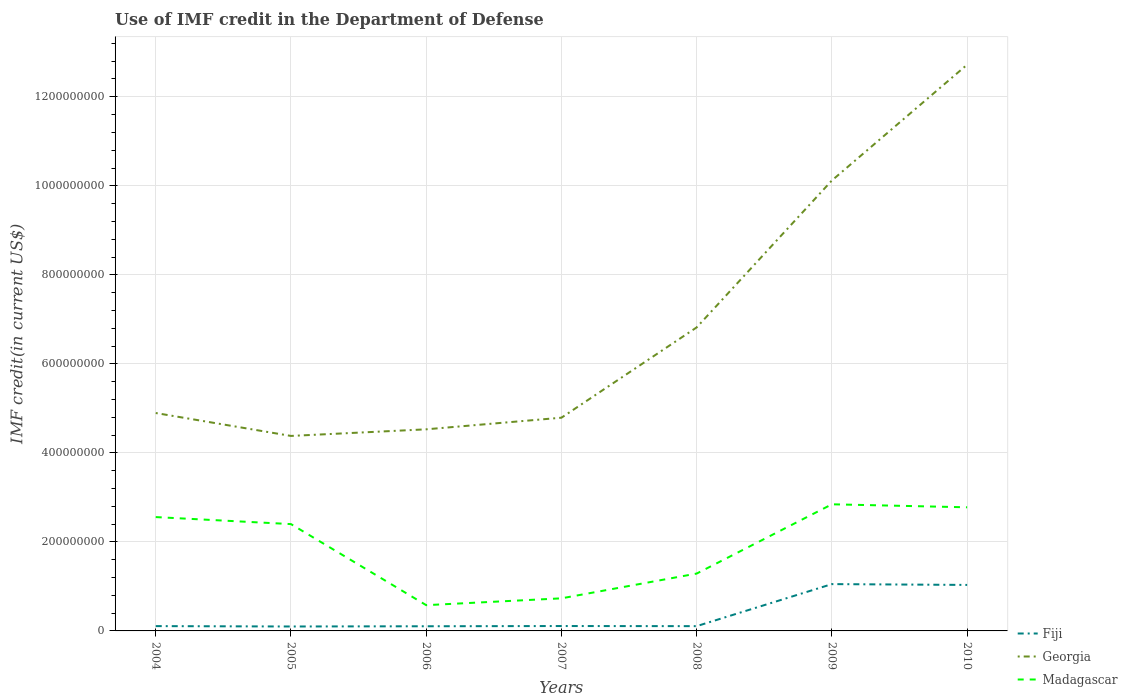How many different coloured lines are there?
Give a very brief answer. 3. Is the number of lines equal to the number of legend labels?
Your answer should be very brief. Yes. Across all years, what is the maximum IMF credit in the Department of Defense in Fiji?
Give a very brief answer. 9.94e+06. What is the total IMF credit in the Department of Defense in Fiji in the graph?
Keep it short and to the point. -1.89e+05. What is the difference between the highest and the second highest IMF credit in the Department of Defense in Georgia?
Keep it short and to the point. 8.34e+08. What is the difference between the highest and the lowest IMF credit in the Department of Defense in Madagascar?
Keep it short and to the point. 4. Is the IMF credit in the Department of Defense in Fiji strictly greater than the IMF credit in the Department of Defense in Georgia over the years?
Keep it short and to the point. Yes. How many lines are there?
Make the answer very short. 3. How many years are there in the graph?
Offer a terse response. 7. Are the values on the major ticks of Y-axis written in scientific E-notation?
Keep it short and to the point. No. Does the graph contain any zero values?
Your response must be concise. No. Where does the legend appear in the graph?
Your answer should be very brief. Bottom right. How are the legend labels stacked?
Offer a very short reply. Vertical. What is the title of the graph?
Ensure brevity in your answer.  Use of IMF credit in the Department of Defense. Does "Philippines" appear as one of the legend labels in the graph?
Your answer should be very brief. No. What is the label or title of the X-axis?
Your answer should be compact. Years. What is the label or title of the Y-axis?
Provide a succinct answer. IMF credit(in current US$). What is the IMF credit(in current US$) in Fiji in 2004?
Give a very brief answer. 1.08e+07. What is the IMF credit(in current US$) of Georgia in 2004?
Your answer should be very brief. 4.90e+08. What is the IMF credit(in current US$) of Madagascar in 2004?
Provide a short and direct response. 2.56e+08. What is the IMF credit(in current US$) in Fiji in 2005?
Give a very brief answer. 9.94e+06. What is the IMF credit(in current US$) in Georgia in 2005?
Your answer should be very brief. 4.38e+08. What is the IMF credit(in current US$) of Madagascar in 2005?
Give a very brief answer. 2.40e+08. What is the IMF credit(in current US$) of Fiji in 2006?
Your response must be concise. 1.05e+07. What is the IMF credit(in current US$) of Georgia in 2006?
Ensure brevity in your answer.  4.53e+08. What is the IMF credit(in current US$) in Madagascar in 2006?
Make the answer very short. 5.79e+07. What is the IMF credit(in current US$) of Fiji in 2007?
Offer a terse response. 1.10e+07. What is the IMF credit(in current US$) in Georgia in 2007?
Your answer should be very brief. 4.79e+08. What is the IMF credit(in current US$) in Madagascar in 2007?
Your answer should be very brief. 7.32e+07. What is the IMF credit(in current US$) in Fiji in 2008?
Give a very brief answer. 1.07e+07. What is the IMF credit(in current US$) of Georgia in 2008?
Make the answer very short. 6.82e+08. What is the IMF credit(in current US$) in Madagascar in 2008?
Offer a terse response. 1.29e+08. What is the IMF credit(in current US$) in Fiji in 2009?
Make the answer very short. 1.05e+08. What is the IMF credit(in current US$) in Georgia in 2009?
Your response must be concise. 1.01e+09. What is the IMF credit(in current US$) in Madagascar in 2009?
Offer a terse response. 2.84e+08. What is the IMF credit(in current US$) of Fiji in 2010?
Offer a terse response. 1.03e+08. What is the IMF credit(in current US$) of Georgia in 2010?
Keep it short and to the point. 1.27e+09. What is the IMF credit(in current US$) of Madagascar in 2010?
Your answer should be compact. 2.78e+08. Across all years, what is the maximum IMF credit(in current US$) in Fiji?
Your answer should be very brief. 1.05e+08. Across all years, what is the maximum IMF credit(in current US$) in Georgia?
Your answer should be very brief. 1.27e+09. Across all years, what is the maximum IMF credit(in current US$) of Madagascar?
Give a very brief answer. 2.84e+08. Across all years, what is the minimum IMF credit(in current US$) of Fiji?
Offer a terse response. 9.94e+06. Across all years, what is the minimum IMF credit(in current US$) in Georgia?
Provide a short and direct response. 4.38e+08. Across all years, what is the minimum IMF credit(in current US$) of Madagascar?
Provide a short and direct response. 5.79e+07. What is the total IMF credit(in current US$) of Fiji in the graph?
Make the answer very short. 2.61e+08. What is the total IMF credit(in current US$) in Georgia in the graph?
Provide a succinct answer. 4.83e+09. What is the total IMF credit(in current US$) of Madagascar in the graph?
Your answer should be compact. 1.32e+09. What is the difference between the IMF credit(in current US$) of Fiji in 2004 and that in 2005?
Make the answer very short. 8.61e+05. What is the difference between the IMF credit(in current US$) of Georgia in 2004 and that in 2005?
Ensure brevity in your answer.  5.15e+07. What is the difference between the IMF credit(in current US$) in Madagascar in 2004 and that in 2005?
Make the answer very short. 1.58e+07. What is the difference between the IMF credit(in current US$) of Fiji in 2004 and that in 2006?
Give a very brief answer. 3.38e+05. What is the difference between the IMF credit(in current US$) in Georgia in 2004 and that in 2006?
Ensure brevity in your answer.  3.66e+07. What is the difference between the IMF credit(in current US$) of Madagascar in 2004 and that in 2006?
Your answer should be very brief. 1.98e+08. What is the difference between the IMF credit(in current US$) in Fiji in 2004 and that in 2007?
Give a very brief answer. -1.89e+05. What is the difference between the IMF credit(in current US$) of Georgia in 2004 and that in 2007?
Ensure brevity in your answer.  1.05e+07. What is the difference between the IMF credit(in current US$) of Madagascar in 2004 and that in 2007?
Provide a succinct answer. 1.83e+08. What is the difference between the IMF credit(in current US$) of Fiji in 2004 and that in 2008?
Provide a succinct answer. 8.90e+04. What is the difference between the IMF credit(in current US$) of Georgia in 2004 and that in 2008?
Make the answer very short. -1.92e+08. What is the difference between the IMF credit(in current US$) in Madagascar in 2004 and that in 2008?
Make the answer very short. 1.27e+08. What is the difference between the IMF credit(in current US$) in Fiji in 2004 and that in 2009?
Your answer should be very brief. -9.44e+07. What is the difference between the IMF credit(in current US$) in Georgia in 2004 and that in 2009?
Your response must be concise. -5.22e+08. What is the difference between the IMF credit(in current US$) of Madagascar in 2004 and that in 2009?
Give a very brief answer. -2.87e+07. What is the difference between the IMF credit(in current US$) of Fiji in 2004 and that in 2010?
Your answer should be very brief. -9.25e+07. What is the difference between the IMF credit(in current US$) of Georgia in 2004 and that in 2010?
Offer a terse response. -7.83e+08. What is the difference between the IMF credit(in current US$) in Madagascar in 2004 and that in 2010?
Provide a succinct answer. -2.19e+07. What is the difference between the IMF credit(in current US$) in Fiji in 2005 and that in 2006?
Keep it short and to the point. -5.23e+05. What is the difference between the IMF credit(in current US$) of Georgia in 2005 and that in 2006?
Provide a succinct answer. -1.49e+07. What is the difference between the IMF credit(in current US$) in Madagascar in 2005 and that in 2006?
Offer a terse response. 1.82e+08. What is the difference between the IMF credit(in current US$) of Fiji in 2005 and that in 2007?
Your response must be concise. -1.05e+06. What is the difference between the IMF credit(in current US$) of Georgia in 2005 and that in 2007?
Keep it short and to the point. -4.10e+07. What is the difference between the IMF credit(in current US$) of Madagascar in 2005 and that in 2007?
Ensure brevity in your answer.  1.67e+08. What is the difference between the IMF credit(in current US$) in Fiji in 2005 and that in 2008?
Ensure brevity in your answer.  -7.72e+05. What is the difference between the IMF credit(in current US$) in Georgia in 2005 and that in 2008?
Give a very brief answer. -2.44e+08. What is the difference between the IMF credit(in current US$) in Madagascar in 2005 and that in 2008?
Ensure brevity in your answer.  1.11e+08. What is the difference between the IMF credit(in current US$) of Fiji in 2005 and that in 2009?
Offer a terse response. -9.52e+07. What is the difference between the IMF credit(in current US$) in Georgia in 2005 and that in 2009?
Your response must be concise. -5.74e+08. What is the difference between the IMF credit(in current US$) of Madagascar in 2005 and that in 2009?
Provide a short and direct response. -4.45e+07. What is the difference between the IMF credit(in current US$) of Fiji in 2005 and that in 2010?
Ensure brevity in your answer.  -9.34e+07. What is the difference between the IMF credit(in current US$) in Georgia in 2005 and that in 2010?
Provide a succinct answer. -8.34e+08. What is the difference between the IMF credit(in current US$) of Madagascar in 2005 and that in 2010?
Provide a short and direct response. -3.77e+07. What is the difference between the IMF credit(in current US$) of Fiji in 2006 and that in 2007?
Keep it short and to the point. -5.27e+05. What is the difference between the IMF credit(in current US$) of Georgia in 2006 and that in 2007?
Keep it short and to the point. -2.61e+07. What is the difference between the IMF credit(in current US$) of Madagascar in 2006 and that in 2007?
Make the answer very short. -1.53e+07. What is the difference between the IMF credit(in current US$) in Fiji in 2006 and that in 2008?
Offer a terse response. -2.49e+05. What is the difference between the IMF credit(in current US$) in Georgia in 2006 and that in 2008?
Provide a short and direct response. -2.29e+08. What is the difference between the IMF credit(in current US$) in Madagascar in 2006 and that in 2008?
Your answer should be compact. -7.10e+07. What is the difference between the IMF credit(in current US$) of Fiji in 2006 and that in 2009?
Provide a short and direct response. -9.47e+07. What is the difference between the IMF credit(in current US$) in Georgia in 2006 and that in 2009?
Offer a very short reply. -5.59e+08. What is the difference between the IMF credit(in current US$) in Madagascar in 2006 and that in 2009?
Provide a succinct answer. -2.27e+08. What is the difference between the IMF credit(in current US$) of Fiji in 2006 and that in 2010?
Your response must be concise. -9.29e+07. What is the difference between the IMF credit(in current US$) in Georgia in 2006 and that in 2010?
Offer a terse response. -8.19e+08. What is the difference between the IMF credit(in current US$) of Madagascar in 2006 and that in 2010?
Offer a very short reply. -2.20e+08. What is the difference between the IMF credit(in current US$) in Fiji in 2007 and that in 2008?
Your answer should be very brief. 2.78e+05. What is the difference between the IMF credit(in current US$) of Georgia in 2007 and that in 2008?
Make the answer very short. -2.03e+08. What is the difference between the IMF credit(in current US$) of Madagascar in 2007 and that in 2008?
Your answer should be very brief. -5.56e+07. What is the difference between the IMF credit(in current US$) of Fiji in 2007 and that in 2009?
Your answer should be compact. -9.42e+07. What is the difference between the IMF credit(in current US$) of Georgia in 2007 and that in 2009?
Offer a terse response. -5.33e+08. What is the difference between the IMF credit(in current US$) of Madagascar in 2007 and that in 2009?
Your response must be concise. -2.11e+08. What is the difference between the IMF credit(in current US$) in Fiji in 2007 and that in 2010?
Offer a terse response. -9.23e+07. What is the difference between the IMF credit(in current US$) in Georgia in 2007 and that in 2010?
Your answer should be very brief. -7.93e+08. What is the difference between the IMF credit(in current US$) in Madagascar in 2007 and that in 2010?
Your answer should be very brief. -2.05e+08. What is the difference between the IMF credit(in current US$) in Fiji in 2008 and that in 2009?
Your response must be concise. -9.45e+07. What is the difference between the IMF credit(in current US$) of Georgia in 2008 and that in 2009?
Your answer should be very brief. -3.30e+08. What is the difference between the IMF credit(in current US$) in Madagascar in 2008 and that in 2009?
Ensure brevity in your answer.  -1.56e+08. What is the difference between the IMF credit(in current US$) of Fiji in 2008 and that in 2010?
Provide a succinct answer. -9.26e+07. What is the difference between the IMF credit(in current US$) of Georgia in 2008 and that in 2010?
Keep it short and to the point. -5.90e+08. What is the difference between the IMF credit(in current US$) in Madagascar in 2008 and that in 2010?
Keep it short and to the point. -1.49e+08. What is the difference between the IMF credit(in current US$) of Fiji in 2009 and that in 2010?
Ensure brevity in your answer.  1.86e+06. What is the difference between the IMF credit(in current US$) in Georgia in 2009 and that in 2010?
Provide a short and direct response. -2.60e+08. What is the difference between the IMF credit(in current US$) in Madagascar in 2009 and that in 2010?
Give a very brief answer. 6.77e+06. What is the difference between the IMF credit(in current US$) in Fiji in 2004 and the IMF credit(in current US$) in Georgia in 2005?
Your answer should be very brief. -4.27e+08. What is the difference between the IMF credit(in current US$) in Fiji in 2004 and the IMF credit(in current US$) in Madagascar in 2005?
Your answer should be very brief. -2.29e+08. What is the difference between the IMF credit(in current US$) of Georgia in 2004 and the IMF credit(in current US$) of Madagascar in 2005?
Offer a very short reply. 2.50e+08. What is the difference between the IMF credit(in current US$) of Fiji in 2004 and the IMF credit(in current US$) of Georgia in 2006?
Offer a terse response. -4.42e+08. What is the difference between the IMF credit(in current US$) of Fiji in 2004 and the IMF credit(in current US$) of Madagascar in 2006?
Keep it short and to the point. -4.71e+07. What is the difference between the IMF credit(in current US$) in Georgia in 2004 and the IMF credit(in current US$) in Madagascar in 2006?
Give a very brief answer. 4.32e+08. What is the difference between the IMF credit(in current US$) of Fiji in 2004 and the IMF credit(in current US$) of Georgia in 2007?
Offer a very short reply. -4.68e+08. What is the difference between the IMF credit(in current US$) of Fiji in 2004 and the IMF credit(in current US$) of Madagascar in 2007?
Your answer should be very brief. -6.24e+07. What is the difference between the IMF credit(in current US$) in Georgia in 2004 and the IMF credit(in current US$) in Madagascar in 2007?
Your response must be concise. 4.16e+08. What is the difference between the IMF credit(in current US$) of Fiji in 2004 and the IMF credit(in current US$) of Georgia in 2008?
Offer a very short reply. -6.71e+08. What is the difference between the IMF credit(in current US$) in Fiji in 2004 and the IMF credit(in current US$) in Madagascar in 2008?
Provide a succinct answer. -1.18e+08. What is the difference between the IMF credit(in current US$) in Georgia in 2004 and the IMF credit(in current US$) in Madagascar in 2008?
Keep it short and to the point. 3.61e+08. What is the difference between the IMF credit(in current US$) of Fiji in 2004 and the IMF credit(in current US$) of Georgia in 2009?
Your response must be concise. -1.00e+09. What is the difference between the IMF credit(in current US$) of Fiji in 2004 and the IMF credit(in current US$) of Madagascar in 2009?
Your response must be concise. -2.74e+08. What is the difference between the IMF credit(in current US$) of Georgia in 2004 and the IMF credit(in current US$) of Madagascar in 2009?
Ensure brevity in your answer.  2.05e+08. What is the difference between the IMF credit(in current US$) of Fiji in 2004 and the IMF credit(in current US$) of Georgia in 2010?
Ensure brevity in your answer.  -1.26e+09. What is the difference between the IMF credit(in current US$) of Fiji in 2004 and the IMF credit(in current US$) of Madagascar in 2010?
Give a very brief answer. -2.67e+08. What is the difference between the IMF credit(in current US$) in Georgia in 2004 and the IMF credit(in current US$) in Madagascar in 2010?
Your answer should be very brief. 2.12e+08. What is the difference between the IMF credit(in current US$) of Fiji in 2005 and the IMF credit(in current US$) of Georgia in 2006?
Your response must be concise. -4.43e+08. What is the difference between the IMF credit(in current US$) of Fiji in 2005 and the IMF credit(in current US$) of Madagascar in 2006?
Provide a short and direct response. -4.79e+07. What is the difference between the IMF credit(in current US$) of Georgia in 2005 and the IMF credit(in current US$) of Madagascar in 2006?
Provide a short and direct response. 3.80e+08. What is the difference between the IMF credit(in current US$) in Fiji in 2005 and the IMF credit(in current US$) in Georgia in 2007?
Provide a short and direct response. -4.69e+08. What is the difference between the IMF credit(in current US$) in Fiji in 2005 and the IMF credit(in current US$) in Madagascar in 2007?
Your answer should be compact. -6.33e+07. What is the difference between the IMF credit(in current US$) in Georgia in 2005 and the IMF credit(in current US$) in Madagascar in 2007?
Your answer should be very brief. 3.65e+08. What is the difference between the IMF credit(in current US$) in Fiji in 2005 and the IMF credit(in current US$) in Georgia in 2008?
Make the answer very short. -6.72e+08. What is the difference between the IMF credit(in current US$) of Fiji in 2005 and the IMF credit(in current US$) of Madagascar in 2008?
Your response must be concise. -1.19e+08. What is the difference between the IMF credit(in current US$) of Georgia in 2005 and the IMF credit(in current US$) of Madagascar in 2008?
Provide a short and direct response. 3.09e+08. What is the difference between the IMF credit(in current US$) of Fiji in 2005 and the IMF credit(in current US$) of Georgia in 2009?
Give a very brief answer. -1.00e+09. What is the difference between the IMF credit(in current US$) of Fiji in 2005 and the IMF credit(in current US$) of Madagascar in 2009?
Provide a succinct answer. -2.75e+08. What is the difference between the IMF credit(in current US$) in Georgia in 2005 and the IMF credit(in current US$) in Madagascar in 2009?
Provide a succinct answer. 1.54e+08. What is the difference between the IMF credit(in current US$) of Fiji in 2005 and the IMF credit(in current US$) of Georgia in 2010?
Keep it short and to the point. -1.26e+09. What is the difference between the IMF credit(in current US$) in Fiji in 2005 and the IMF credit(in current US$) in Madagascar in 2010?
Give a very brief answer. -2.68e+08. What is the difference between the IMF credit(in current US$) in Georgia in 2005 and the IMF credit(in current US$) in Madagascar in 2010?
Offer a very short reply. 1.60e+08. What is the difference between the IMF credit(in current US$) in Fiji in 2006 and the IMF credit(in current US$) in Georgia in 2007?
Ensure brevity in your answer.  -4.69e+08. What is the difference between the IMF credit(in current US$) in Fiji in 2006 and the IMF credit(in current US$) in Madagascar in 2007?
Your response must be concise. -6.27e+07. What is the difference between the IMF credit(in current US$) of Georgia in 2006 and the IMF credit(in current US$) of Madagascar in 2007?
Offer a very short reply. 3.80e+08. What is the difference between the IMF credit(in current US$) of Fiji in 2006 and the IMF credit(in current US$) of Georgia in 2008?
Provide a succinct answer. -6.71e+08. What is the difference between the IMF credit(in current US$) in Fiji in 2006 and the IMF credit(in current US$) in Madagascar in 2008?
Ensure brevity in your answer.  -1.18e+08. What is the difference between the IMF credit(in current US$) of Georgia in 2006 and the IMF credit(in current US$) of Madagascar in 2008?
Offer a terse response. 3.24e+08. What is the difference between the IMF credit(in current US$) in Fiji in 2006 and the IMF credit(in current US$) in Georgia in 2009?
Offer a terse response. -1.00e+09. What is the difference between the IMF credit(in current US$) of Fiji in 2006 and the IMF credit(in current US$) of Madagascar in 2009?
Provide a succinct answer. -2.74e+08. What is the difference between the IMF credit(in current US$) of Georgia in 2006 and the IMF credit(in current US$) of Madagascar in 2009?
Provide a succinct answer. 1.68e+08. What is the difference between the IMF credit(in current US$) of Fiji in 2006 and the IMF credit(in current US$) of Georgia in 2010?
Provide a short and direct response. -1.26e+09. What is the difference between the IMF credit(in current US$) in Fiji in 2006 and the IMF credit(in current US$) in Madagascar in 2010?
Make the answer very short. -2.67e+08. What is the difference between the IMF credit(in current US$) of Georgia in 2006 and the IMF credit(in current US$) of Madagascar in 2010?
Offer a very short reply. 1.75e+08. What is the difference between the IMF credit(in current US$) of Fiji in 2007 and the IMF credit(in current US$) of Georgia in 2008?
Your response must be concise. -6.71e+08. What is the difference between the IMF credit(in current US$) in Fiji in 2007 and the IMF credit(in current US$) in Madagascar in 2008?
Your answer should be very brief. -1.18e+08. What is the difference between the IMF credit(in current US$) of Georgia in 2007 and the IMF credit(in current US$) of Madagascar in 2008?
Keep it short and to the point. 3.50e+08. What is the difference between the IMF credit(in current US$) in Fiji in 2007 and the IMF credit(in current US$) in Georgia in 2009?
Your answer should be compact. -1.00e+09. What is the difference between the IMF credit(in current US$) in Fiji in 2007 and the IMF credit(in current US$) in Madagascar in 2009?
Offer a very short reply. -2.73e+08. What is the difference between the IMF credit(in current US$) of Georgia in 2007 and the IMF credit(in current US$) of Madagascar in 2009?
Keep it short and to the point. 1.95e+08. What is the difference between the IMF credit(in current US$) in Fiji in 2007 and the IMF credit(in current US$) in Georgia in 2010?
Your response must be concise. -1.26e+09. What is the difference between the IMF credit(in current US$) in Fiji in 2007 and the IMF credit(in current US$) in Madagascar in 2010?
Your answer should be very brief. -2.67e+08. What is the difference between the IMF credit(in current US$) in Georgia in 2007 and the IMF credit(in current US$) in Madagascar in 2010?
Keep it short and to the point. 2.01e+08. What is the difference between the IMF credit(in current US$) in Fiji in 2008 and the IMF credit(in current US$) in Georgia in 2009?
Make the answer very short. -1.00e+09. What is the difference between the IMF credit(in current US$) in Fiji in 2008 and the IMF credit(in current US$) in Madagascar in 2009?
Provide a short and direct response. -2.74e+08. What is the difference between the IMF credit(in current US$) in Georgia in 2008 and the IMF credit(in current US$) in Madagascar in 2009?
Offer a very short reply. 3.97e+08. What is the difference between the IMF credit(in current US$) in Fiji in 2008 and the IMF credit(in current US$) in Georgia in 2010?
Keep it short and to the point. -1.26e+09. What is the difference between the IMF credit(in current US$) of Fiji in 2008 and the IMF credit(in current US$) of Madagascar in 2010?
Your answer should be very brief. -2.67e+08. What is the difference between the IMF credit(in current US$) of Georgia in 2008 and the IMF credit(in current US$) of Madagascar in 2010?
Offer a very short reply. 4.04e+08. What is the difference between the IMF credit(in current US$) of Fiji in 2009 and the IMF credit(in current US$) of Georgia in 2010?
Provide a short and direct response. -1.17e+09. What is the difference between the IMF credit(in current US$) of Fiji in 2009 and the IMF credit(in current US$) of Madagascar in 2010?
Ensure brevity in your answer.  -1.73e+08. What is the difference between the IMF credit(in current US$) in Georgia in 2009 and the IMF credit(in current US$) in Madagascar in 2010?
Offer a very short reply. 7.34e+08. What is the average IMF credit(in current US$) in Fiji per year?
Provide a short and direct response. 3.73e+07. What is the average IMF credit(in current US$) of Georgia per year?
Provide a short and direct response. 6.89e+08. What is the average IMF credit(in current US$) of Madagascar per year?
Your answer should be compact. 1.88e+08. In the year 2004, what is the difference between the IMF credit(in current US$) in Fiji and IMF credit(in current US$) in Georgia?
Provide a short and direct response. -4.79e+08. In the year 2004, what is the difference between the IMF credit(in current US$) of Fiji and IMF credit(in current US$) of Madagascar?
Provide a succinct answer. -2.45e+08. In the year 2004, what is the difference between the IMF credit(in current US$) of Georgia and IMF credit(in current US$) of Madagascar?
Provide a succinct answer. 2.34e+08. In the year 2005, what is the difference between the IMF credit(in current US$) in Fiji and IMF credit(in current US$) in Georgia?
Give a very brief answer. -4.28e+08. In the year 2005, what is the difference between the IMF credit(in current US$) of Fiji and IMF credit(in current US$) of Madagascar?
Keep it short and to the point. -2.30e+08. In the year 2005, what is the difference between the IMF credit(in current US$) of Georgia and IMF credit(in current US$) of Madagascar?
Your answer should be very brief. 1.98e+08. In the year 2006, what is the difference between the IMF credit(in current US$) in Fiji and IMF credit(in current US$) in Georgia?
Offer a very short reply. -4.42e+08. In the year 2006, what is the difference between the IMF credit(in current US$) in Fiji and IMF credit(in current US$) in Madagascar?
Provide a succinct answer. -4.74e+07. In the year 2006, what is the difference between the IMF credit(in current US$) of Georgia and IMF credit(in current US$) of Madagascar?
Give a very brief answer. 3.95e+08. In the year 2007, what is the difference between the IMF credit(in current US$) in Fiji and IMF credit(in current US$) in Georgia?
Your answer should be very brief. -4.68e+08. In the year 2007, what is the difference between the IMF credit(in current US$) of Fiji and IMF credit(in current US$) of Madagascar?
Provide a succinct answer. -6.22e+07. In the year 2007, what is the difference between the IMF credit(in current US$) in Georgia and IMF credit(in current US$) in Madagascar?
Offer a terse response. 4.06e+08. In the year 2008, what is the difference between the IMF credit(in current US$) of Fiji and IMF credit(in current US$) of Georgia?
Your response must be concise. -6.71e+08. In the year 2008, what is the difference between the IMF credit(in current US$) of Fiji and IMF credit(in current US$) of Madagascar?
Offer a very short reply. -1.18e+08. In the year 2008, what is the difference between the IMF credit(in current US$) in Georgia and IMF credit(in current US$) in Madagascar?
Offer a very short reply. 5.53e+08. In the year 2009, what is the difference between the IMF credit(in current US$) in Fiji and IMF credit(in current US$) in Georgia?
Your answer should be very brief. -9.07e+08. In the year 2009, what is the difference between the IMF credit(in current US$) of Fiji and IMF credit(in current US$) of Madagascar?
Make the answer very short. -1.79e+08. In the year 2009, what is the difference between the IMF credit(in current US$) of Georgia and IMF credit(in current US$) of Madagascar?
Make the answer very short. 7.28e+08. In the year 2010, what is the difference between the IMF credit(in current US$) in Fiji and IMF credit(in current US$) in Georgia?
Keep it short and to the point. -1.17e+09. In the year 2010, what is the difference between the IMF credit(in current US$) of Fiji and IMF credit(in current US$) of Madagascar?
Your answer should be very brief. -1.74e+08. In the year 2010, what is the difference between the IMF credit(in current US$) of Georgia and IMF credit(in current US$) of Madagascar?
Give a very brief answer. 9.94e+08. What is the ratio of the IMF credit(in current US$) in Fiji in 2004 to that in 2005?
Provide a short and direct response. 1.09. What is the ratio of the IMF credit(in current US$) in Georgia in 2004 to that in 2005?
Your answer should be compact. 1.12. What is the ratio of the IMF credit(in current US$) of Madagascar in 2004 to that in 2005?
Offer a very short reply. 1.07. What is the ratio of the IMF credit(in current US$) in Fiji in 2004 to that in 2006?
Provide a short and direct response. 1.03. What is the ratio of the IMF credit(in current US$) in Georgia in 2004 to that in 2006?
Provide a short and direct response. 1.08. What is the ratio of the IMF credit(in current US$) in Madagascar in 2004 to that in 2006?
Ensure brevity in your answer.  4.42. What is the ratio of the IMF credit(in current US$) in Fiji in 2004 to that in 2007?
Your answer should be very brief. 0.98. What is the ratio of the IMF credit(in current US$) of Madagascar in 2004 to that in 2007?
Offer a terse response. 3.49. What is the ratio of the IMF credit(in current US$) in Fiji in 2004 to that in 2008?
Ensure brevity in your answer.  1.01. What is the ratio of the IMF credit(in current US$) of Georgia in 2004 to that in 2008?
Provide a succinct answer. 0.72. What is the ratio of the IMF credit(in current US$) of Madagascar in 2004 to that in 2008?
Make the answer very short. 1.99. What is the ratio of the IMF credit(in current US$) of Fiji in 2004 to that in 2009?
Keep it short and to the point. 0.1. What is the ratio of the IMF credit(in current US$) of Georgia in 2004 to that in 2009?
Make the answer very short. 0.48. What is the ratio of the IMF credit(in current US$) in Madagascar in 2004 to that in 2009?
Provide a short and direct response. 0.9. What is the ratio of the IMF credit(in current US$) of Fiji in 2004 to that in 2010?
Your response must be concise. 0.1. What is the ratio of the IMF credit(in current US$) of Georgia in 2004 to that in 2010?
Keep it short and to the point. 0.38. What is the ratio of the IMF credit(in current US$) in Madagascar in 2004 to that in 2010?
Make the answer very short. 0.92. What is the ratio of the IMF credit(in current US$) in Fiji in 2005 to that in 2006?
Make the answer very short. 0.95. What is the ratio of the IMF credit(in current US$) of Georgia in 2005 to that in 2006?
Your response must be concise. 0.97. What is the ratio of the IMF credit(in current US$) of Madagascar in 2005 to that in 2006?
Provide a succinct answer. 4.15. What is the ratio of the IMF credit(in current US$) in Fiji in 2005 to that in 2007?
Keep it short and to the point. 0.9. What is the ratio of the IMF credit(in current US$) in Georgia in 2005 to that in 2007?
Offer a very short reply. 0.91. What is the ratio of the IMF credit(in current US$) of Madagascar in 2005 to that in 2007?
Provide a succinct answer. 3.28. What is the ratio of the IMF credit(in current US$) in Fiji in 2005 to that in 2008?
Your answer should be very brief. 0.93. What is the ratio of the IMF credit(in current US$) of Georgia in 2005 to that in 2008?
Give a very brief answer. 0.64. What is the ratio of the IMF credit(in current US$) in Madagascar in 2005 to that in 2008?
Give a very brief answer. 1.86. What is the ratio of the IMF credit(in current US$) of Fiji in 2005 to that in 2009?
Give a very brief answer. 0.09. What is the ratio of the IMF credit(in current US$) of Georgia in 2005 to that in 2009?
Your response must be concise. 0.43. What is the ratio of the IMF credit(in current US$) of Madagascar in 2005 to that in 2009?
Make the answer very short. 0.84. What is the ratio of the IMF credit(in current US$) of Fiji in 2005 to that in 2010?
Offer a very short reply. 0.1. What is the ratio of the IMF credit(in current US$) in Georgia in 2005 to that in 2010?
Offer a very short reply. 0.34. What is the ratio of the IMF credit(in current US$) of Madagascar in 2005 to that in 2010?
Your answer should be very brief. 0.86. What is the ratio of the IMF credit(in current US$) of Fiji in 2006 to that in 2007?
Keep it short and to the point. 0.95. What is the ratio of the IMF credit(in current US$) in Georgia in 2006 to that in 2007?
Keep it short and to the point. 0.95. What is the ratio of the IMF credit(in current US$) in Madagascar in 2006 to that in 2007?
Your answer should be compact. 0.79. What is the ratio of the IMF credit(in current US$) of Fiji in 2006 to that in 2008?
Keep it short and to the point. 0.98. What is the ratio of the IMF credit(in current US$) in Georgia in 2006 to that in 2008?
Your response must be concise. 0.66. What is the ratio of the IMF credit(in current US$) of Madagascar in 2006 to that in 2008?
Offer a terse response. 0.45. What is the ratio of the IMF credit(in current US$) of Fiji in 2006 to that in 2009?
Your answer should be compact. 0.1. What is the ratio of the IMF credit(in current US$) in Georgia in 2006 to that in 2009?
Give a very brief answer. 0.45. What is the ratio of the IMF credit(in current US$) of Madagascar in 2006 to that in 2009?
Your response must be concise. 0.2. What is the ratio of the IMF credit(in current US$) in Fiji in 2006 to that in 2010?
Provide a succinct answer. 0.1. What is the ratio of the IMF credit(in current US$) in Georgia in 2006 to that in 2010?
Your response must be concise. 0.36. What is the ratio of the IMF credit(in current US$) of Madagascar in 2006 to that in 2010?
Give a very brief answer. 0.21. What is the ratio of the IMF credit(in current US$) of Fiji in 2007 to that in 2008?
Offer a terse response. 1.03. What is the ratio of the IMF credit(in current US$) of Georgia in 2007 to that in 2008?
Offer a very short reply. 0.7. What is the ratio of the IMF credit(in current US$) in Madagascar in 2007 to that in 2008?
Make the answer very short. 0.57. What is the ratio of the IMF credit(in current US$) in Fiji in 2007 to that in 2009?
Give a very brief answer. 0.1. What is the ratio of the IMF credit(in current US$) of Georgia in 2007 to that in 2009?
Give a very brief answer. 0.47. What is the ratio of the IMF credit(in current US$) of Madagascar in 2007 to that in 2009?
Ensure brevity in your answer.  0.26. What is the ratio of the IMF credit(in current US$) in Fiji in 2007 to that in 2010?
Ensure brevity in your answer.  0.11. What is the ratio of the IMF credit(in current US$) in Georgia in 2007 to that in 2010?
Offer a very short reply. 0.38. What is the ratio of the IMF credit(in current US$) in Madagascar in 2007 to that in 2010?
Make the answer very short. 0.26. What is the ratio of the IMF credit(in current US$) of Fiji in 2008 to that in 2009?
Your answer should be very brief. 0.1. What is the ratio of the IMF credit(in current US$) of Georgia in 2008 to that in 2009?
Your response must be concise. 0.67. What is the ratio of the IMF credit(in current US$) in Madagascar in 2008 to that in 2009?
Your answer should be very brief. 0.45. What is the ratio of the IMF credit(in current US$) of Fiji in 2008 to that in 2010?
Ensure brevity in your answer.  0.1. What is the ratio of the IMF credit(in current US$) in Georgia in 2008 to that in 2010?
Your answer should be very brief. 0.54. What is the ratio of the IMF credit(in current US$) in Madagascar in 2008 to that in 2010?
Offer a terse response. 0.46. What is the ratio of the IMF credit(in current US$) of Georgia in 2009 to that in 2010?
Provide a short and direct response. 0.8. What is the ratio of the IMF credit(in current US$) in Madagascar in 2009 to that in 2010?
Make the answer very short. 1.02. What is the difference between the highest and the second highest IMF credit(in current US$) in Fiji?
Offer a terse response. 1.86e+06. What is the difference between the highest and the second highest IMF credit(in current US$) of Georgia?
Keep it short and to the point. 2.60e+08. What is the difference between the highest and the second highest IMF credit(in current US$) of Madagascar?
Offer a very short reply. 6.77e+06. What is the difference between the highest and the lowest IMF credit(in current US$) in Fiji?
Your answer should be compact. 9.52e+07. What is the difference between the highest and the lowest IMF credit(in current US$) in Georgia?
Give a very brief answer. 8.34e+08. What is the difference between the highest and the lowest IMF credit(in current US$) of Madagascar?
Make the answer very short. 2.27e+08. 